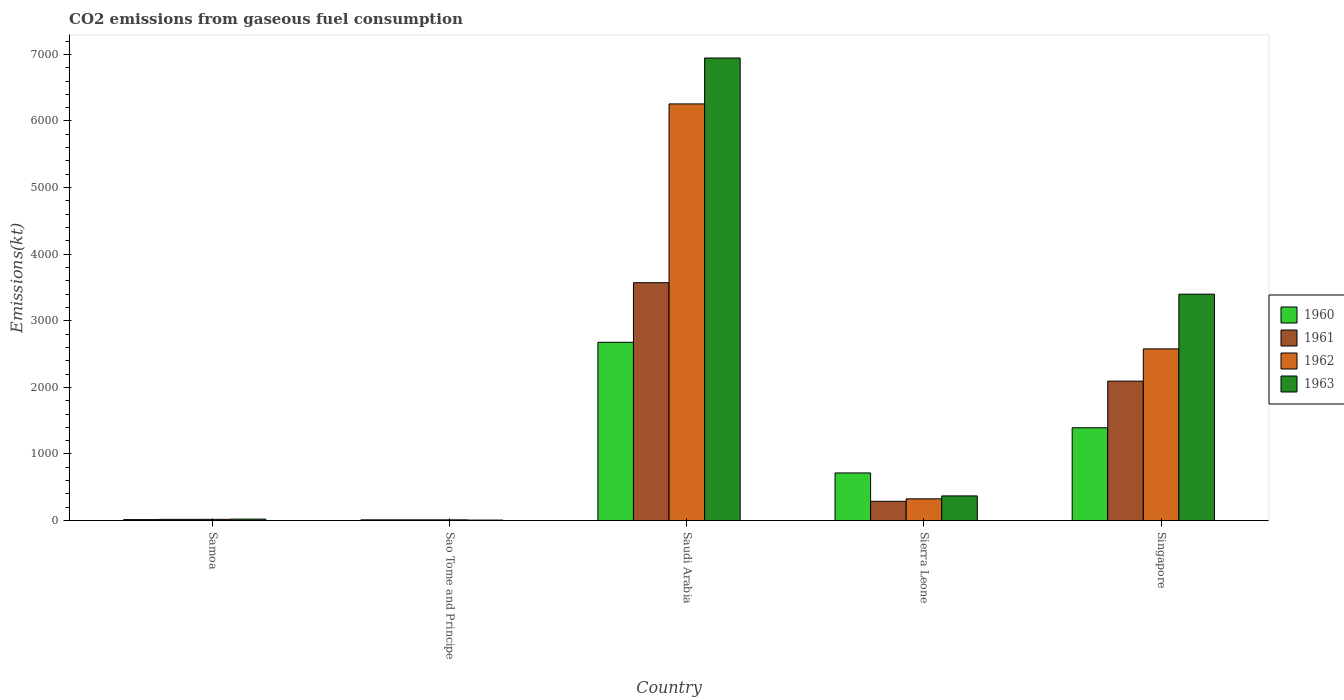How many different coloured bars are there?
Offer a very short reply. 4. How many groups of bars are there?
Offer a terse response. 5. Are the number of bars per tick equal to the number of legend labels?
Offer a terse response. Yes. How many bars are there on the 1st tick from the left?
Offer a very short reply. 4. How many bars are there on the 4th tick from the right?
Ensure brevity in your answer.  4. What is the label of the 2nd group of bars from the left?
Make the answer very short. Sao Tome and Principe. In how many cases, is the number of bars for a given country not equal to the number of legend labels?
Offer a terse response. 0. What is the amount of CO2 emitted in 1962 in Samoa?
Provide a succinct answer. 18.34. Across all countries, what is the maximum amount of CO2 emitted in 1961?
Keep it short and to the point. 3571.66. Across all countries, what is the minimum amount of CO2 emitted in 1961?
Ensure brevity in your answer.  11. In which country was the amount of CO2 emitted in 1960 maximum?
Your answer should be compact. Saudi Arabia. In which country was the amount of CO2 emitted in 1962 minimum?
Offer a very short reply. Sao Tome and Principe. What is the total amount of CO2 emitted in 1961 in the graph?
Offer a terse response. 5984.54. What is the difference between the amount of CO2 emitted in 1961 in Samoa and that in Singapore?
Provide a short and direct response. -2075.52. What is the difference between the amount of CO2 emitted in 1960 in Samoa and the amount of CO2 emitted in 1963 in Saudi Arabia?
Your answer should be very brief. -6930.63. What is the average amount of CO2 emitted in 1962 per country?
Offer a very short reply. 1837.9. What is the difference between the amount of CO2 emitted of/in 1962 and amount of CO2 emitted of/in 1963 in Sierra Leone?
Provide a short and direct response. -44. What is the ratio of the amount of CO2 emitted in 1960 in Saudi Arabia to that in Sierra Leone?
Keep it short and to the point. 3.74. Is the difference between the amount of CO2 emitted in 1962 in Sao Tome and Principe and Sierra Leone greater than the difference between the amount of CO2 emitted in 1963 in Sao Tome and Principe and Sierra Leone?
Offer a terse response. Yes. What is the difference between the highest and the second highest amount of CO2 emitted in 1961?
Ensure brevity in your answer.  -3281.97. What is the difference between the highest and the lowest amount of CO2 emitted in 1963?
Your response must be concise. 6937.96. Is the sum of the amount of CO2 emitted in 1960 in Samoa and Sao Tome and Principe greater than the maximum amount of CO2 emitted in 1963 across all countries?
Your answer should be compact. No. Is it the case that in every country, the sum of the amount of CO2 emitted in 1961 and amount of CO2 emitted in 1960 is greater than the amount of CO2 emitted in 1963?
Give a very brief answer. No. How many bars are there?
Provide a succinct answer. 20. Does the graph contain any zero values?
Offer a very short reply. No. How many legend labels are there?
Provide a short and direct response. 4. How are the legend labels stacked?
Make the answer very short. Vertical. What is the title of the graph?
Ensure brevity in your answer.  CO2 emissions from gaseous fuel consumption. What is the label or title of the Y-axis?
Your answer should be very brief. Emissions(kt). What is the Emissions(kt) in 1960 in Samoa?
Provide a succinct answer. 14.67. What is the Emissions(kt) in 1961 in Samoa?
Make the answer very short. 18.34. What is the Emissions(kt) of 1962 in Samoa?
Ensure brevity in your answer.  18.34. What is the Emissions(kt) of 1963 in Samoa?
Provide a short and direct response. 22. What is the Emissions(kt) in 1960 in Sao Tome and Principe?
Provide a succinct answer. 11. What is the Emissions(kt) in 1961 in Sao Tome and Principe?
Your answer should be compact. 11. What is the Emissions(kt) in 1962 in Sao Tome and Principe?
Provide a succinct answer. 11. What is the Emissions(kt) of 1963 in Sao Tome and Principe?
Your answer should be compact. 7.33. What is the Emissions(kt) of 1960 in Saudi Arabia?
Provide a succinct answer. 2676.91. What is the Emissions(kt) in 1961 in Saudi Arabia?
Give a very brief answer. 3571.66. What is the Emissions(kt) in 1962 in Saudi Arabia?
Offer a terse response. 6255.9. What is the Emissions(kt) in 1963 in Saudi Arabia?
Ensure brevity in your answer.  6945.3. What is the Emissions(kt) in 1960 in Sierra Leone?
Your response must be concise. 715.07. What is the Emissions(kt) of 1961 in Sierra Leone?
Make the answer very short. 289.69. What is the Emissions(kt) of 1962 in Sierra Leone?
Offer a very short reply. 326.36. What is the Emissions(kt) of 1963 in Sierra Leone?
Your answer should be very brief. 370.37. What is the Emissions(kt) of 1960 in Singapore?
Your response must be concise. 1393.46. What is the Emissions(kt) in 1961 in Singapore?
Give a very brief answer. 2093.86. What is the Emissions(kt) in 1962 in Singapore?
Provide a succinct answer. 2577.9. What is the Emissions(kt) in 1963 in Singapore?
Your response must be concise. 3399.31. Across all countries, what is the maximum Emissions(kt) of 1960?
Provide a short and direct response. 2676.91. Across all countries, what is the maximum Emissions(kt) in 1961?
Give a very brief answer. 3571.66. Across all countries, what is the maximum Emissions(kt) in 1962?
Provide a short and direct response. 6255.9. Across all countries, what is the maximum Emissions(kt) of 1963?
Ensure brevity in your answer.  6945.3. Across all countries, what is the minimum Emissions(kt) in 1960?
Provide a short and direct response. 11. Across all countries, what is the minimum Emissions(kt) of 1961?
Provide a short and direct response. 11. Across all countries, what is the minimum Emissions(kt) of 1962?
Provide a succinct answer. 11. Across all countries, what is the minimum Emissions(kt) of 1963?
Provide a short and direct response. 7.33. What is the total Emissions(kt) of 1960 in the graph?
Offer a very short reply. 4811.1. What is the total Emissions(kt) of 1961 in the graph?
Provide a short and direct response. 5984.54. What is the total Emissions(kt) of 1962 in the graph?
Offer a very short reply. 9189.5. What is the total Emissions(kt) of 1963 in the graph?
Offer a terse response. 1.07e+04. What is the difference between the Emissions(kt) of 1960 in Samoa and that in Sao Tome and Principe?
Provide a short and direct response. 3.67. What is the difference between the Emissions(kt) in 1961 in Samoa and that in Sao Tome and Principe?
Your answer should be very brief. 7.33. What is the difference between the Emissions(kt) of 1962 in Samoa and that in Sao Tome and Principe?
Keep it short and to the point. 7.33. What is the difference between the Emissions(kt) in 1963 in Samoa and that in Sao Tome and Principe?
Your answer should be very brief. 14.67. What is the difference between the Emissions(kt) of 1960 in Samoa and that in Saudi Arabia?
Your answer should be compact. -2662.24. What is the difference between the Emissions(kt) of 1961 in Samoa and that in Saudi Arabia?
Offer a terse response. -3553.32. What is the difference between the Emissions(kt) of 1962 in Samoa and that in Saudi Arabia?
Give a very brief answer. -6237.57. What is the difference between the Emissions(kt) of 1963 in Samoa and that in Saudi Arabia?
Keep it short and to the point. -6923.3. What is the difference between the Emissions(kt) in 1960 in Samoa and that in Sierra Leone?
Give a very brief answer. -700.4. What is the difference between the Emissions(kt) of 1961 in Samoa and that in Sierra Leone?
Keep it short and to the point. -271.36. What is the difference between the Emissions(kt) of 1962 in Samoa and that in Sierra Leone?
Offer a terse response. -308.03. What is the difference between the Emissions(kt) in 1963 in Samoa and that in Sierra Leone?
Give a very brief answer. -348.37. What is the difference between the Emissions(kt) of 1960 in Samoa and that in Singapore?
Provide a short and direct response. -1378.79. What is the difference between the Emissions(kt) in 1961 in Samoa and that in Singapore?
Your answer should be compact. -2075.52. What is the difference between the Emissions(kt) in 1962 in Samoa and that in Singapore?
Provide a succinct answer. -2559.57. What is the difference between the Emissions(kt) of 1963 in Samoa and that in Singapore?
Give a very brief answer. -3377.31. What is the difference between the Emissions(kt) in 1960 in Sao Tome and Principe and that in Saudi Arabia?
Keep it short and to the point. -2665.91. What is the difference between the Emissions(kt) of 1961 in Sao Tome and Principe and that in Saudi Arabia?
Keep it short and to the point. -3560.66. What is the difference between the Emissions(kt) of 1962 in Sao Tome and Principe and that in Saudi Arabia?
Your answer should be very brief. -6244.9. What is the difference between the Emissions(kt) of 1963 in Sao Tome and Principe and that in Saudi Arabia?
Give a very brief answer. -6937.96. What is the difference between the Emissions(kt) in 1960 in Sao Tome and Principe and that in Sierra Leone?
Your answer should be very brief. -704.06. What is the difference between the Emissions(kt) in 1961 in Sao Tome and Principe and that in Sierra Leone?
Provide a succinct answer. -278.69. What is the difference between the Emissions(kt) of 1962 in Sao Tome and Principe and that in Sierra Leone?
Give a very brief answer. -315.36. What is the difference between the Emissions(kt) of 1963 in Sao Tome and Principe and that in Sierra Leone?
Offer a very short reply. -363.03. What is the difference between the Emissions(kt) in 1960 in Sao Tome and Principe and that in Singapore?
Offer a very short reply. -1382.46. What is the difference between the Emissions(kt) of 1961 in Sao Tome and Principe and that in Singapore?
Your answer should be compact. -2082.86. What is the difference between the Emissions(kt) in 1962 in Sao Tome and Principe and that in Singapore?
Ensure brevity in your answer.  -2566.9. What is the difference between the Emissions(kt) of 1963 in Sao Tome and Principe and that in Singapore?
Your answer should be very brief. -3391.97. What is the difference between the Emissions(kt) of 1960 in Saudi Arabia and that in Sierra Leone?
Offer a very short reply. 1961.85. What is the difference between the Emissions(kt) of 1961 in Saudi Arabia and that in Sierra Leone?
Keep it short and to the point. 3281.97. What is the difference between the Emissions(kt) of 1962 in Saudi Arabia and that in Sierra Leone?
Ensure brevity in your answer.  5929.54. What is the difference between the Emissions(kt) in 1963 in Saudi Arabia and that in Sierra Leone?
Offer a terse response. 6574.93. What is the difference between the Emissions(kt) in 1960 in Saudi Arabia and that in Singapore?
Ensure brevity in your answer.  1283.45. What is the difference between the Emissions(kt) of 1961 in Saudi Arabia and that in Singapore?
Your answer should be very brief. 1477.8. What is the difference between the Emissions(kt) in 1962 in Saudi Arabia and that in Singapore?
Your response must be concise. 3678. What is the difference between the Emissions(kt) in 1963 in Saudi Arabia and that in Singapore?
Offer a terse response. 3545.99. What is the difference between the Emissions(kt) of 1960 in Sierra Leone and that in Singapore?
Make the answer very short. -678.39. What is the difference between the Emissions(kt) in 1961 in Sierra Leone and that in Singapore?
Your response must be concise. -1804.16. What is the difference between the Emissions(kt) of 1962 in Sierra Leone and that in Singapore?
Keep it short and to the point. -2251.54. What is the difference between the Emissions(kt) in 1963 in Sierra Leone and that in Singapore?
Keep it short and to the point. -3028.94. What is the difference between the Emissions(kt) in 1960 in Samoa and the Emissions(kt) in 1961 in Sao Tome and Principe?
Your answer should be compact. 3.67. What is the difference between the Emissions(kt) in 1960 in Samoa and the Emissions(kt) in 1962 in Sao Tome and Principe?
Keep it short and to the point. 3.67. What is the difference between the Emissions(kt) of 1960 in Samoa and the Emissions(kt) of 1963 in Sao Tome and Principe?
Offer a very short reply. 7.33. What is the difference between the Emissions(kt) of 1961 in Samoa and the Emissions(kt) of 1962 in Sao Tome and Principe?
Offer a very short reply. 7.33. What is the difference between the Emissions(kt) of 1961 in Samoa and the Emissions(kt) of 1963 in Sao Tome and Principe?
Your answer should be very brief. 11. What is the difference between the Emissions(kt) in 1962 in Samoa and the Emissions(kt) in 1963 in Sao Tome and Principe?
Make the answer very short. 11. What is the difference between the Emissions(kt) of 1960 in Samoa and the Emissions(kt) of 1961 in Saudi Arabia?
Provide a succinct answer. -3556.99. What is the difference between the Emissions(kt) in 1960 in Samoa and the Emissions(kt) in 1962 in Saudi Arabia?
Your answer should be compact. -6241.23. What is the difference between the Emissions(kt) in 1960 in Samoa and the Emissions(kt) in 1963 in Saudi Arabia?
Give a very brief answer. -6930.63. What is the difference between the Emissions(kt) in 1961 in Samoa and the Emissions(kt) in 1962 in Saudi Arabia?
Ensure brevity in your answer.  -6237.57. What is the difference between the Emissions(kt) in 1961 in Samoa and the Emissions(kt) in 1963 in Saudi Arabia?
Provide a succinct answer. -6926.96. What is the difference between the Emissions(kt) of 1962 in Samoa and the Emissions(kt) of 1963 in Saudi Arabia?
Your response must be concise. -6926.96. What is the difference between the Emissions(kt) of 1960 in Samoa and the Emissions(kt) of 1961 in Sierra Leone?
Offer a terse response. -275.02. What is the difference between the Emissions(kt) in 1960 in Samoa and the Emissions(kt) in 1962 in Sierra Leone?
Provide a short and direct response. -311.69. What is the difference between the Emissions(kt) of 1960 in Samoa and the Emissions(kt) of 1963 in Sierra Leone?
Provide a short and direct response. -355.7. What is the difference between the Emissions(kt) in 1961 in Samoa and the Emissions(kt) in 1962 in Sierra Leone?
Offer a terse response. -308.03. What is the difference between the Emissions(kt) in 1961 in Samoa and the Emissions(kt) in 1963 in Sierra Leone?
Give a very brief answer. -352.03. What is the difference between the Emissions(kt) of 1962 in Samoa and the Emissions(kt) of 1963 in Sierra Leone?
Your answer should be very brief. -352.03. What is the difference between the Emissions(kt) in 1960 in Samoa and the Emissions(kt) in 1961 in Singapore?
Offer a very short reply. -2079.19. What is the difference between the Emissions(kt) in 1960 in Samoa and the Emissions(kt) in 1962 in Singapore?
Offer a terse response. -2563.23. What is the difference between the Emissions(kt) in 1960 in Samoa and the Emissions(kt) in 1963 in Singapore?
Offer a terse response. -3384.64. What is the difference between the Emissions(kt) of 1961 in Samoa and the Emissions(kt) of 1962 in Singapore?
Make the answer very short. -2559.57. What is the difference between the Emissions(kt) of 1961 in Samoa and the Emissions(kt) of 1963 in Singapore?
Make the answer very short. -3380.97. What is the difference between the Emissions(kt) of 1962 in Samoa and the Emissions(kt) of 1963 in Singapore?
Your response must be concise. -3380.97. What is the difference between the Emissions(kt) in 1960 in Sao Tome and Principe and the Emissions(kt) in 1961 in Saudi Arabia?
Provide a short and direct response. -3560.66. What is the difference between the Emissions(kt) in 1960 in Sao Tome and Principe and the Emissions(kt) in 1962 in Saudi Arabia?
Offer a terse response. -6244.9. What is the difference between the Emissions(kt) of 1960 in Sao Tome and Principe and the Emissions(kt) of 1963 in Saudi Arabia?
Offer a very short reply. -6934.3. What is the difference between the Emissions(kt) of 1961 in Sao Tome and Principe and the Emissions(kt) of 1962 in Saudi Arabia?
Ensure brevity in your answer.  -6244.9. What is the difference between the Emissions(kt) in 1961 in Sao Tome and Principe and the Emissions(kt) in 1963 in Saudi Arabia?
Make the answer very short. -6934.3. What is the difference between the Emissions(kt) of 1962 in Sao Tome and Principe and the Emissions(kt) of 1963 in Saudi Arabia?
Your response must be concise. -6934.3. What is the difference between the Emissions(kt) in 1960 in Sao Tome and Principe and the Emissions(kt) in 1961 in Sierra Leone?
Make the answer very short. -278.69. What is the difference between the Emissions(kt) of 1960 in Sao Tome and Principe and the Emissions(kt) of 1962 in Sierra Leone?
Give a very brief answer. -315.36. What is the difference between the Emissions(kt) in 1960 in Sao Tome and Principe and the Emissions(kt) in 1963 in Sierra Leone?
Offer a very short reply. -359.37. What is the difference between the Emissions(kt) of 1961 in Sao Tome and Principe and the Emissions(kt) of 1962 in Sierra Leone?
Your response must be concise. -315.36. What is the difference between the Emissions(kt) of 1961 in Sao Tome and Principe and the Emissions(kt) of 1963 in Sierra Leone?
Your answer should be very brief. -359.37. What is the difference between the Emissions(kt) in 1962 in Sao Tome and Principe and the Emissions(kt) in 1963 in Sierra Leone?
Give a very brief answer. -359.37. What is the difference between the Emissions(kt) of 1960 in Sao Tome and Principe and the Emissions(kt) of 1961 in Singapore?
Make the answer very short. -2082.86. What is the difference between the Emissions(kt) in 1960 in Sao Tome and Principe and the Emissions(kt) in 1962 in Singapore?
Your answer should be compact. -2566.9. What is the difference between the Emissions(kt) in 1960 in Sao Tome and Principe and the Emissions(kt) in 1963 in Singapore?
Make the answer very short. -3388.31. What is the difference between the Emissions(kt) of 1961 in Sao Tome and Principe and the Emissions(kt) of 1962 in Singapore?
Your answer should be very brief. -2566.9. What is the difference between the Emissions(kt) of 1961 in Sao Tome and Principe and the Emissions(kt) of 1963 in Singapore?
Offer a very short reply. -3388.31. What is the difference between the Emissions(kt) in 1962 in Sao Tome and Principe and the Emissions(kt) in 1963 in Singapore?
Give a very brief answer. -3388.31. What is the difference between the Emissions(kt) in 1960 in Saudi Arabia and the Emissions(kt) in 1961 in Sierra Leone?
Offer a terse response. 2387.22. What is the difference between the Emissions(kt) of 1960 in Saudi Arabia and the Emissions(kt) of 1962 in Sierra Leone?
Offer a very short reply. 2350.55. What is the difference between the Emissions(kt) of 1960 in Saudi Arabia and the Emissions(kt) of 1963 in Sierra Leone?
Offer a very short reply. 2306.54. What is the difference between the Emissions(kt) of 1961 in Saudi Arabia and the Emissions(kt) of 1962 in Sierra Leone?
Your response must be concise. 3245.3. What is the difference between the Emissions(kt) in 1961 in Saudi Arabia and the Emissions(kt) in 1963 in Sierra Leone?
Offer a very short reply. 3201.29. What is the difference between the Emissions(kt) in 1962 in Saudi Arabia and the Emissions(kt) in 1963 in Sierra Leone?
Your answer should be compact. 5885.53. What is the difference between the Emissions(kt) of 1960 in Saudi Arabia and the Emissions(kt) of 1961 in Singapore?
Give a very brief answer. 583.05. What is the difference between the Emissions(kt) in 1960 in Saudi Arabia and the Emissions(kt) in 1962 in Singapore?
Your answer should be compact. 99.01. What is the difference between the Emissions(kt) of 1960 in Saudi Arabia and the Emissions(kt) of 1963 in Singapore?
Keep it short and to the point. -722.4. What is the difference between the Emissions(kt) in 1961 in Saudi Arabia and the Emissions(kt) in 1962 in Singapore?
Give a very brief answer. 993.76. What is the difference between the Emissions(kt) of 1961 in Saudi Arabia and the Emissions(kt) of 1963 in Singapore?
Keep it short and to the point. 172.35. What is the difference between the Emissions(kt) in 1962 in Saudi Arabia and the Emissions(kt) in 1963 in Singapore?
Provide a succinct answer. 2856.59. What is the difference between the Emissions(kt) in 1960 in Sierra Leone and the Emissions(kt) in 1961 in Singapore?
Your response must be concise. -1378.79. What is the difference between the Emissions(kt) of 1960 in Sierra Leone and the Emissions(kt) of 1962 in Singapore?
Provide a short and direct response. -1862.84. What is the difference between the Emissions(kt) in 1960 in Sierra Leone and the Emissions(kt) in 1963 in Singapore?
Your response must be concise. -2684.24. What is the difference between the Emissions(kt) in 1961 in Sierra Leone and the Emissions(kt) in 1962 in Singapore?
Offer a terse response. -2288.21. What is the difference between the Emissions(kt) of 1961 in Sierra Leone and the Emissions(kt) of 1963 in Singapore?
Your answer should be compact. -3109.62. What is the difference between the Emissions(kt) in 1962 in Sierra Leone and the Emissions(kt) in 1963 in Singapore?
Offer a terse response. -3072.95. What is the average Emissions(kt) of 1960 per country?
Ensure brevity in your answer.  962.22. What is the average Emissions(kt) in 1961 per country?
Ensure brevity in your answer.  1196.91. What is the average Emissions(kt) in 1962 per country?
Ensure brevity in your answer.  1837.9. What is the average Emissions(kt) in 1963 per country?
Ensure brevity in your answer.  2148.86. What is the difference between the Emissions(kt) of 1960 and Emissions(kt) of 1961 in Samoa?
Give a very brief answer. -3.67. What is the difference between the Emissions(kt) in 1960 and Emissions(kt) in 1962 in Samoa?
Provide a short and direct response. -3.67. What is the difference between the Emissions(kt) of 1960 and Emissions(kt) of 1963 in Samoa?
Your answer should be very brief. -7.33. What is the difference between the Emissions(kt) of 1961 and Emissions(kt) of 1962 in Samoa?
Offer a terse response. 0. What is the difference between the Emissions(kt) in 1961 and Emissions(kt) in 1963 in Samoa?
Offer a very short reply. -3.67. What is the difference between the Emissions(kt) in 1962 and Emissions(kt) in 1963 in Samoa?
Your answer should be compact. -3.67. What is the difference between the Emissions(kt) of 1960 and Emissions(kt) of 1961 in Sao Tome and Principe?
Provide a succinct answer. 0. What is the difference between the Emissions(kt) of 1960 and Emissions(kt) of 1963 in Sao Tome and Principe?
Offer a very short reply. 3.67. What is the difference between the Emissions(kt) in 1961 and Emissions(kt) in 1963 in Sao Tome and Principe?
Your answer should be very brief. 3.67. What is the difference between the Emissions(kt) of 1962 and Emissions(kt) of 1963 in Sao Tome and Principe?
Give a very brief answer. 3.67. What is the difference between the Emissions(kt) of 1960 and Emissions(kt) of 1961 in Saudi Arabia?
Provide a succinct answer. -894.75. What is the difference between the Emissions(kt) in 1960 and Emissions(kt) in 1962 in Saudi Arabia?
Ensure brevity in your answer.  -3578.99. What is the difference between the Emissions(kt) of 1960 and Emissions(kt) of 1963 in Saudi Arabia?
Ensure brevity in your answer.  -4268.39. What is the difference between the Emissions(kt) in 1961 and Emissions(kt) in 1962 in Saudi Arabia?
Provide a short and direct response. -2684.24. What is the difference between the Emissions(kt) in 1961 and Emissions(kt) in 1963 in Saudi Arabia?
Offer a terse response. -3373.64. What is the difference between the Emissions(kt) of 1962 and Emissions(kt) of 1963 in Saudi Arabia?
Your response must be concise. -689.4. What is the difference between the Emissions(kt) in 1960 and Emissions(kt) in 1961 in Sierra Leone?
Your answer should be very brief. 425.37. What is the difference between the Emissions(kt) of 1960 and Emissions(kt) of 1962 in Sierra Leone?
Offer a very short reply. 388.7. What is the difference between the Emissions(kt) in 1960 and Emissions(kt) in 1963 in Sierra Leone?
Make the answer very short. 344.7. What is the difference between the Emissions(kt) in 1961 and Emissions(kt) in 1962 in Sierra Leone?
Make the answer very short. -36.67. What is the difference between the Emissions(kt) in 1961 and Emissions(kt) in 1963 in Sierra Leone?
Your answer should be compact. -80.67. What is the difference between the Emissions(kt) in 1962 and Emissions(kt) in 1963 in Sierra Leone?
Keep it short and to the point. -44. What is the difference between the Emissions(kt) in 1960 and Emissions(kt) in 1961 in Singapore?
Make the answer very short. -700.4. What is the difference between the Emissions(kt) of 1960 and Emissions(kt) of 1962 in Singapore?
Your response must be concise. -1184.44. What is the difference between the Emissions(kt) in 1960 and Emissions(kt) in 1963 in Singapore?
Your response must be concise. -2005.85. What is the difference between the Emissions(kt) in 1961 and Emissions(kt) in 1962 in Singapore?
Give a very brief answer. -484.04. What is the difference between the Emissions(kt) of 1961 and Emissions(kt) of 1963 in Singapore?
Keep it short and to the point. -1305.45. What is the difference between the Emissions(kt) of 1962 and Emissions(kt) of 1963 in Singapore?
Your answer should be compact. -821.41. What is the ratio of the Emissions(kt) in 1961 in Samoa to that in Sao Tome and Principe?
Your response must be concise. 1.67. What is the ratio of the Emissions(kt) of 1962 in Samoa to that in Sao Tome and Principe?
Your answer should be very brief. 1.67. What is the ratio of the Emissions(kt) of 1963 in Samoa to that in Sao Tome and Principe?
Make the answer very short. 3. What is the ratio of the Emissions(kt) in 1960 in Samoa to that in Saudi Arabia?
Your answer should be compact. 0.01. What is the ratio of the Emissions(kt) of 1961 in Samoa to that in Saudi Arabia?
Ensure brevity in your answer.  0.01. What is the ratio of the Emissions(kt) in 1962 in Samoa to that in Saudi Arabia?
Ensure brevity in your answer.  0. What is the ratio of the Emissions(kt) in 1963 in Samoa to that in Saudi Arabia?
Your response must be concise. 0. What is the ratio of the Emissions(kt) of 1960 in Samoa to that in Sierra Leone?
Make the answer very short. 0.02. What is the ratio of the Emissions(kt) in 1961 in Samoa to that in Sierra Leone?
Your response must be concise. 0.06. What is the ratio of the Emissions(kt) of 1962 in Samoa to that in Sierra Leone?
Offer a very short reply. 0.06. What is the ratio of the Emissions(kt) of 1963 in Samoa to that in Sierra Leone?
Provide a succinct answer. 0.06. What is the ratio of the Emissions(kt) of 1960 in Samoa to that in Singapore?
Ensure brevity in your answer.  0.01. What is the ratio of the Emissions(kt) in 1961 in Samoa to that in Singapore?
Offer a terse response. 0.01. What is the ratio of the Emissions(kt) of 1962 in Samoa to that in Singapore?
Your answer should be very brief. 0.01. What is the ratio of the Emissions(kt) of 1963 in Samoa to that in Singapore?
Provide a succinct answer. 0.01. What is the ratio of the Emissions(kt) in 1960 in Sao Tome and Principe to that in Saudi Arabia?
Offer a terse response. 0. What is the ratio of the Emissions(kt) of 1961 in Sao Tome and Principe to that in Saudi Arabia?
Provide a succinct answer. 0. What is the ratio of the Emissions(kt) of 1962 in Sao Tome and Principe to that in Saudi Arabia?
Offer a very short reply. 0. What is the ratio of the Emissions(kt) of 1963 in Sao Tome and Principe to that in Saudi Arabia?
Keep it short and to the point. 0. What is the ratio of the Emissions(kt) of 1960 in Sao Tome and Principe to that in Sierra Leone?
Offer a terse response. 0.02. What is the ratio of the Emissions(kt) of 1961 in Sao Tome and Principe to that in Sierra Leone?
Keep it short and to the point. 0.04. What is the ratio of the Emissions(kt) of 1962 in Sao Tome and Principe to that in Sierra Leone?
Ensure brevity in your answer.  0.03. What is the ratio of the Emissions(kt) in 1963 in Sao Tome and Principe to that in Sierra Leone?
Provide a succinct answer. 0.02. What is the ratio of the Emissions(kt) of 1960 in Sao Tome and Principe to that in Singapore?
Give a very brief answer. 0.01. What is the ratio of the Emissions(kt) in 1961 in Sao Tome and Principe to that in Singapore?
Give a very brief answer. 0.01. What is the ratio of the Emissions(kt) of 1962 in Sao Tome and Principe to that in Singapore?
Your answer should be very brief. 0. What is the ratio of the Emissions(kt) in 1963 in Sao Tome and Principe to that in Singapore?
Offer a terse response. 0. What is the ratio of the Emissions(kt) of 1960 in Saudi Arabia to that in Sierra Leone?
Offer a very short reply. 3.74. What is the ratio of the Emissions(kt) in 1961 in Saudi Arabia to that in Sierra Leone?
Your answer should be compact. 12.33. What is the ratio of the Emissions(kt) in 1962 in Saudi Arabia to that in Sierra Leone?
Make the answer very short. 19.17. What is the ratio of the Emissions(kt) of 1963 in Saudi Arabia to that in Sierra Leone?
Your answer should be compact. 18.75. What is the ratio of the Emissions(kt) in 1960 in Saudi Arabia to that in Singapore?
Offer a very short reply. 1.92. What is the ratio of the Emissions(kt) of 1961 in Saudi Arabia to that in Singapore?
Your response must be concise. 1.71. What is the ratio of the Emissions(kt) in 1962 in Saudi Arabia to that in Singapore?
Give a very brief answer. 2.43. What is the ratio of the Emissions(kt) in 1963 in Saudi Arabia to that in Singapore?
Your answer should be very brief. 2.04. What is the ratio of the Emissions(kt) in 1960 in Sierra Leone to that in Singapore?
Ensure brevity in your answer.  0.51. What is the ratio of the Emissions(kt) in 1961 in Sierra Leone to that in Singapore?
Ensure brevity in your answer.  0.14. What is the ratio of the Emissions(kt) in 1962 in Sierra Leone to that in Singapore?
Your answer should be very brief. 0.13. What is the ratio of the Emissions(kt) in 1963 in Sierra Leone to that in Singapore?
Provide a short and direct response. 0.11. What is the difference between the highest and the second highest Emissions(kt) in 1960?
Give a very brief answer. 1283.45. What is the difference between the highest and the second highest Emissions(kt) of 1961?
Offer a very short reply. 1477.8. What is the difference between the highest and the second highest Emissions(kt) in 1962?
Your answer should be very brief. 3678. What is the difference between the highest and the second highest Emissions(kt) of 1963?
Your response must be concise. 3545.99. What is the difference between the highest and the lowest Emissions(kt) in 1960?
Provide a succinct answer. 2665.91. What is the difference between the highest and the lowest Emissions(kt) of 1961?
Offer a very short reply. 3560.66. What is the difference between the highest and the lowest Emissions(kt) in 1962?
Give a very brief answer. 6244.9. What is the difference between the highest and the lowest Emissions(kt) of 1963?
Keep it short and to the point. 6937.96. 